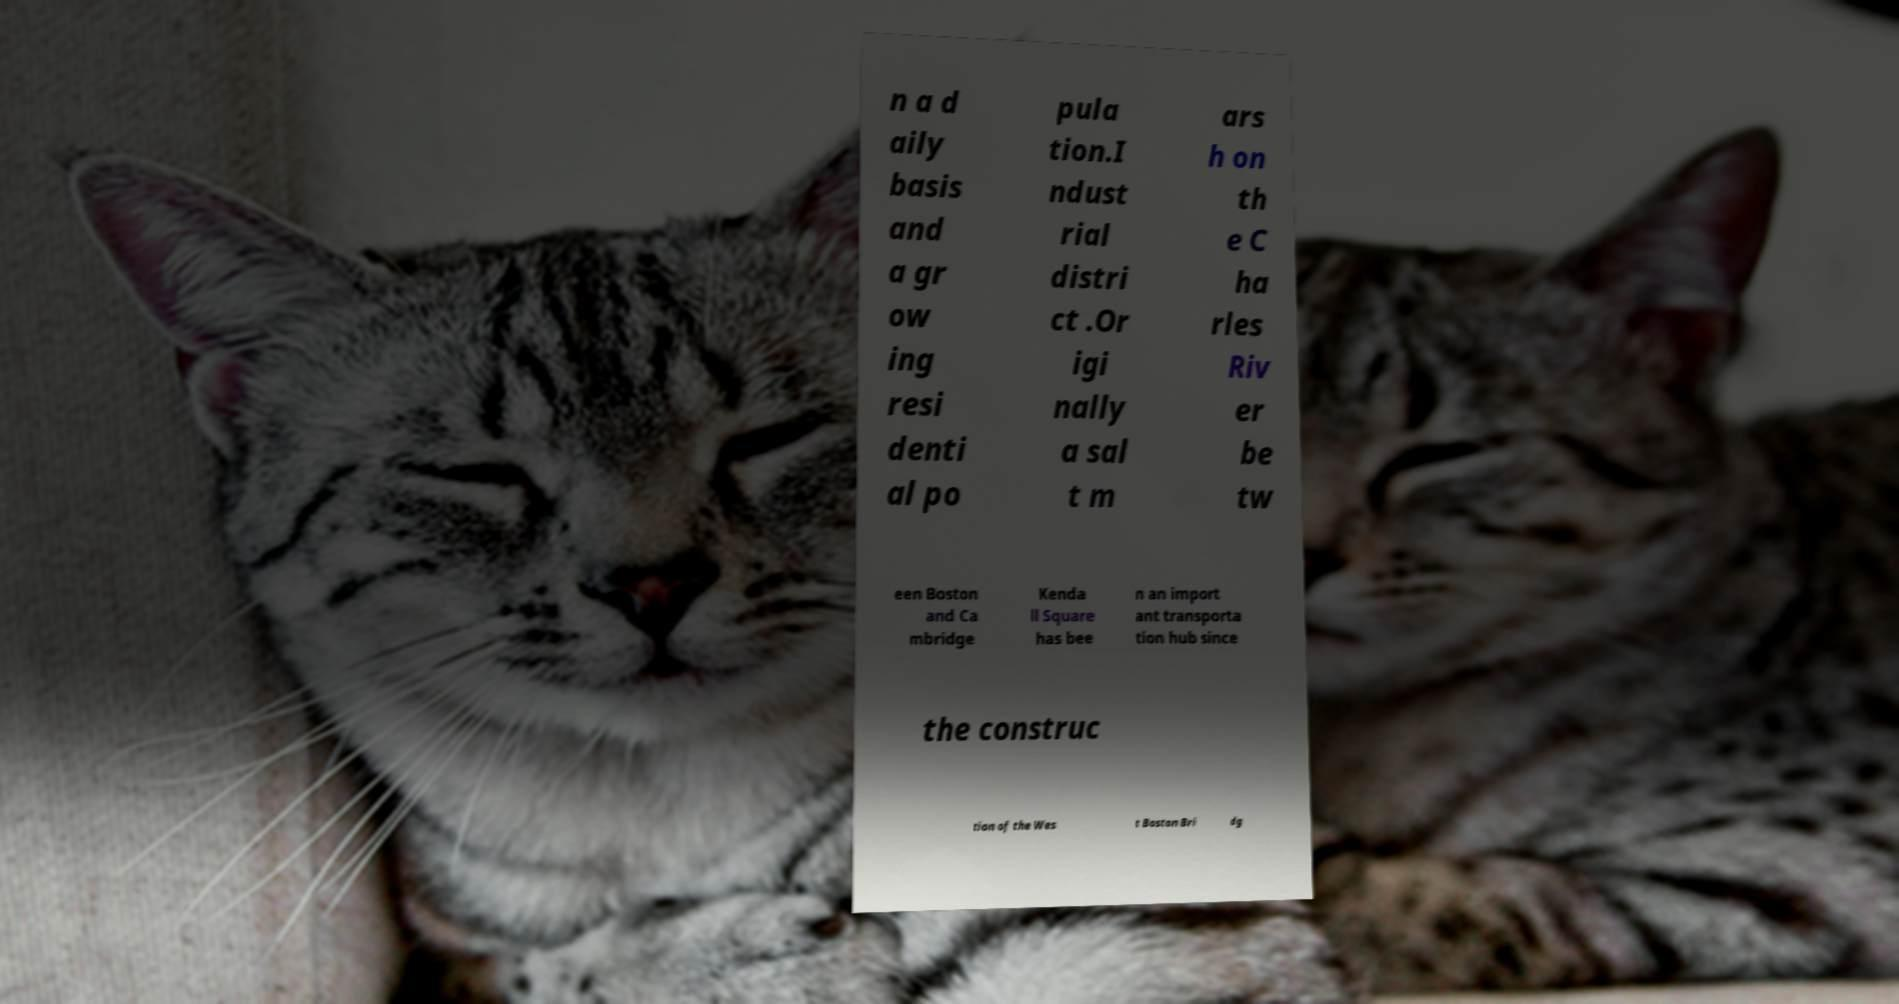I need the written content from this picture converted into text. Can you do that? n a d aily basis and a gr ow ing resi denti al po pula tion.I ndust rial distri ct .Or igi nally a sal t m ars h on th e C ha rles Riv er be tw een Boston and Ca mbridge Kenda ll Square has bee n an import ant transporta tion hub since the construc tion of the Wes t Boston Bri dg 